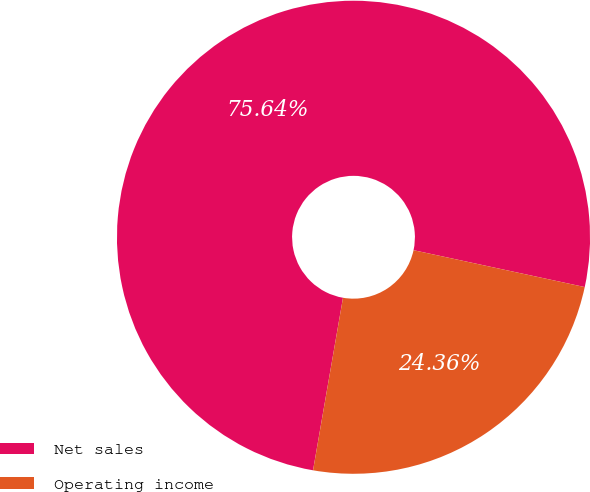Convert chart to OTSL. <chart><loc_0><loc_0><loc_500><loc_500><pie_chart><fcel>Net sales<fcel>Operating income<nl><fcel>75.64%<fcel>24.36%<nl></chart> 